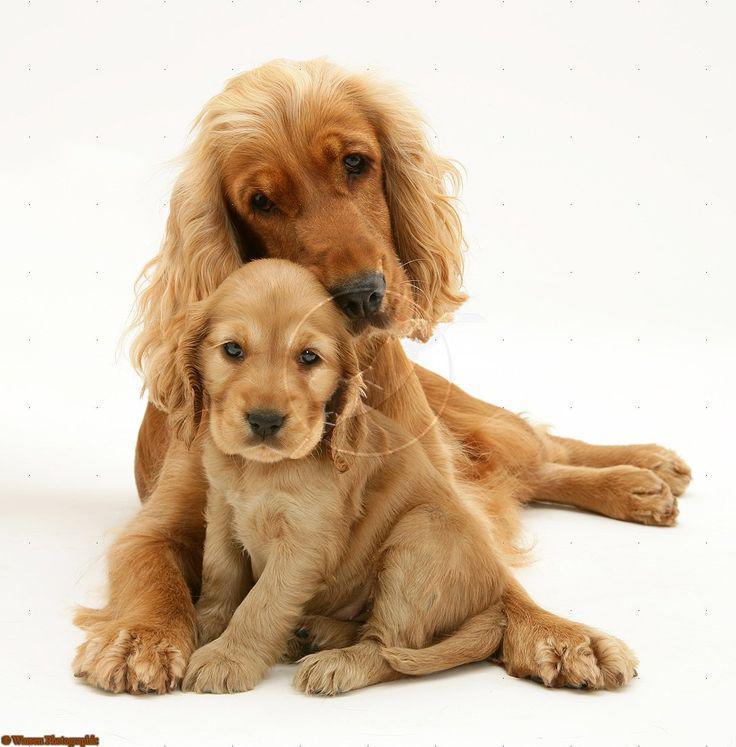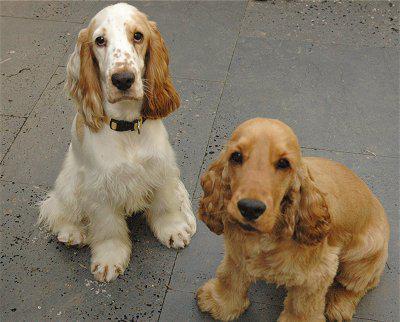The first image is the image on the left, the second image is the image on the right. For the images displayed, is the sentence "A total of two dogs are shown, with none of them standing." factually correct? Answer yes or no. No. The first image is the image on the left, the second image is the image on the right. Given the left and right images, does the statement "The sky can be seen in the background of one of the images." hold true? Answer yes or no. No. 